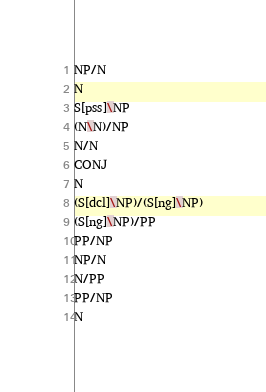Convert code to text. <code><loc_0><loc_0><loc_500><loc_500><_C_>NP/N
N
S[pss]\NP
(N\N)/NP
N/N
CONJ
N
(S[dcl]\NP)/(S[ng]\NP)
(S[ng]\NP)/PP
PP/NP
NP/N
N/PP
PP/NP
N
</code> 